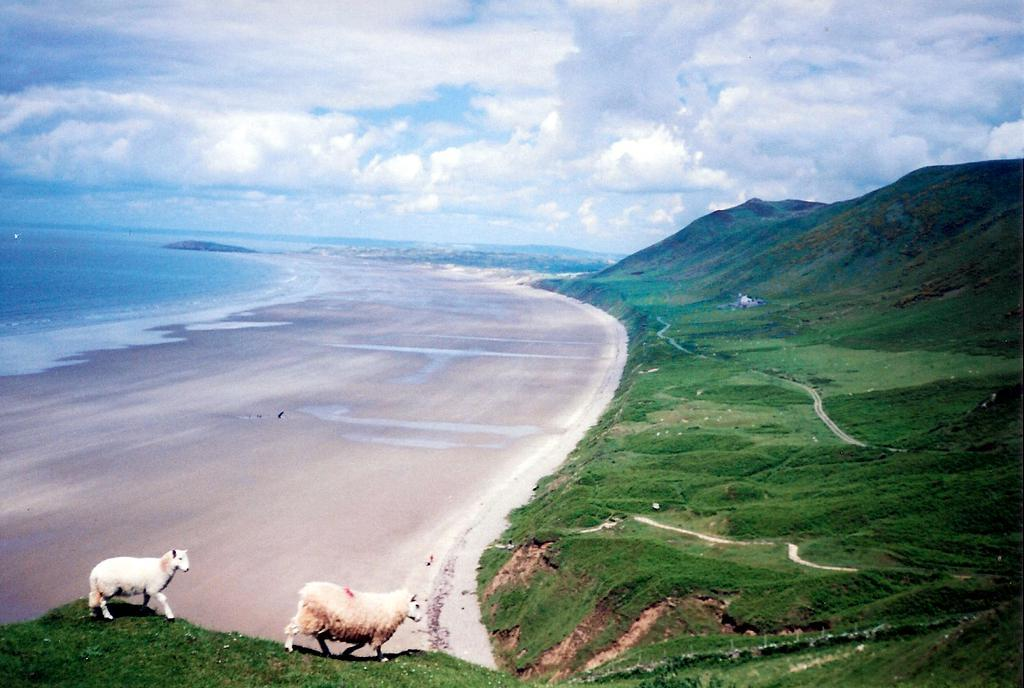What type of landscape is depicted in the image? There is a beach and mountains with grass in the image. What animals can be seen in the mountains? Two sheep are walking on the grass. How many tickets are needed to enter the beach in the image? There is no mention of tickets or any entrance requirement in the image; it simply shows a beach and mountains with grass. 